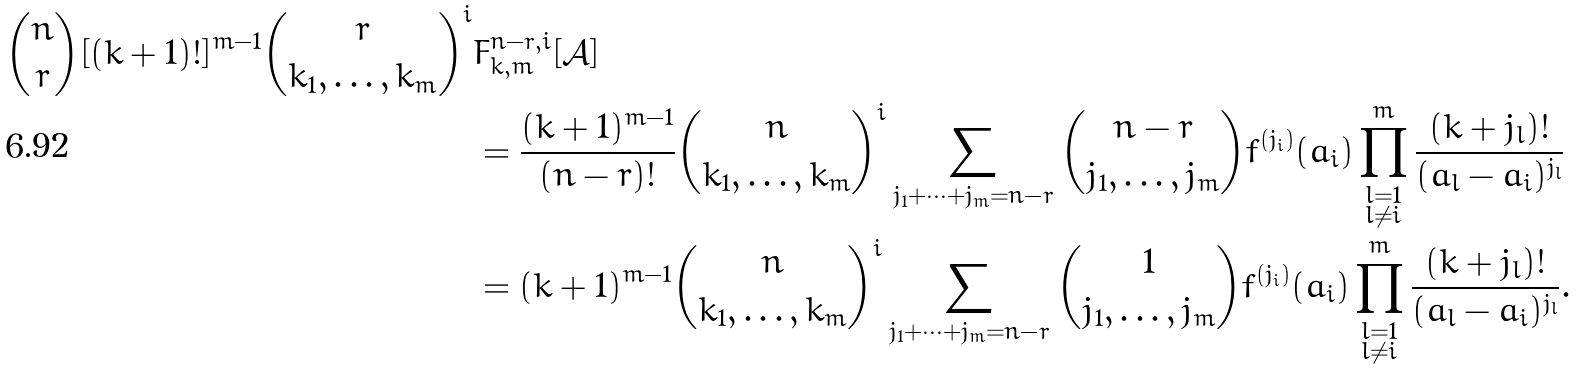Convert formula to latex. <formula><loc_0><loc_0><loc_500><loc_500>\binom { n } { r } [ ( k + 1 ) ! ] ^ { m - 1 } \binom { r } { k _ { 1 } , \dots , k _ { m } } ^ { i } & F ^ { n - r , i } _ { k , m } [ \mathcal { A } ] \\ & = \frac { ( k + 1 ) ^ { m - 1 } } { ( n - r ) ! } \binom { n } { k _ { 1 } , \dots , k _ { m } } ^ { i } \sum _ { j _ { 1 } + \dots + j _ { m } = n - r } \binom { n - r } { j _ { 1 } , \dots , j _ { m } } f ^ { ( j _ { i } ) } ( a _ { i } ) \prod ^ { m } _ { \substack { l = 1 \\ l \neq i } } \frac { ( k + j _ { l } ) ! } { ( a _ { l } - a _ { i } ) ^ { j _ { l } } } \\ & = ( k + 1 ) ^ { m - 1 } \binom { n } { k _ { 1 } , \dots , k _ { m } } ^ { i } \sum _ { j _ { 1 } + \dots + j _ { m } = n - r } \binom { 1 } { j _ { 1 } , \dots , j _ { m } } f ^ { ( j _ { i } ) } ( a _ { i } ) \prod ^ { m } _ { \substack { l = 1 \\ l \neq i } } \frac { ( k + j _ { l } ) ! } { ( a _ { l } - a _ { i } ) ^ { j _ { l } } } . \\</formula> 